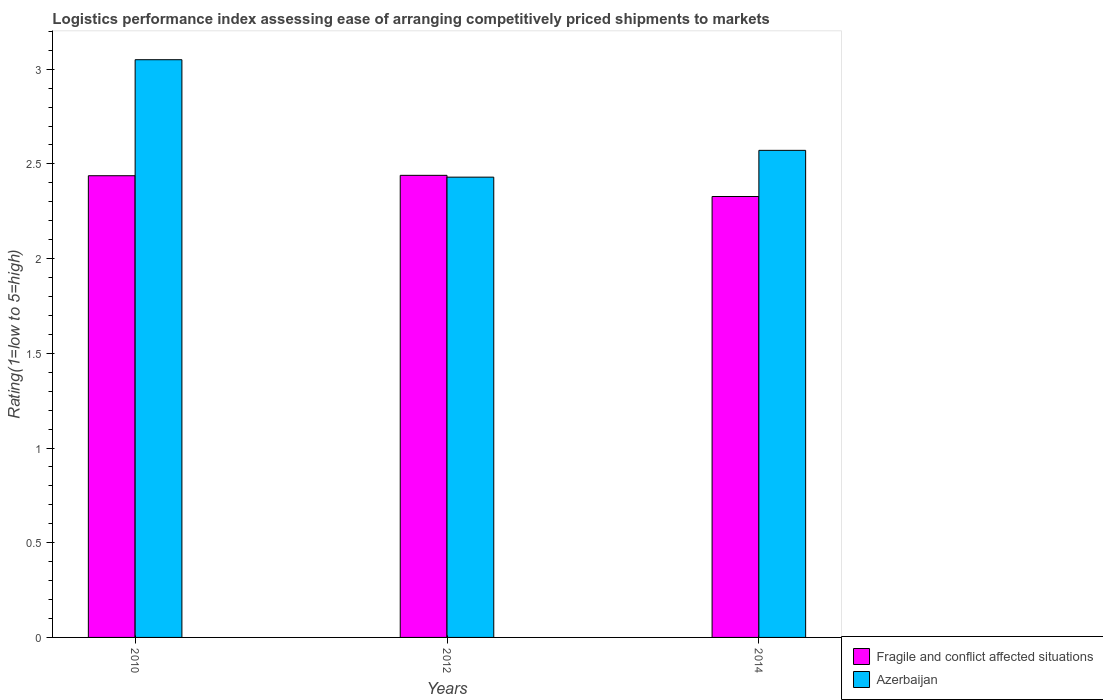How many bars are there on the 2nd tick from the left?
Your answer should be compact. 2. How many bars are there on the 1st tick from the right?
Make the answer very short. 2. What is the label of the 3rd group of bars from the left?
Ensure brevity in your answer.  2014. In how many cases, is the number of bars for a given year not equal to the number of legend labels?
Your answer should be compact. 0. What is the Logistic performance index in Azerbaijan in 2014?
Offer a very short reply. 2.57. Across all years, what is the maximum Logistic performance index in Azerbaijan?
Your answer should be compact. 3.05. Across all years, what is the minimum Logistic performance index in Fragile and conflict affected situations?
Your answer should be very brief. 2.33. In which year was the Logistic performance index in Azerbaijan maximum?
Ensure brevity in your answer.  2010. In which year was the Logistic performance index in Fragile and conflict affected situations minimum?
Provide a succinct answer. 2014. What is the total Logistic performance index in Azerbaijan in the graph?
Keep it short and to the point. 8.05. What is the difference between the Logistic performance index in Fragile and conflict affected situations in 2012 and that in 2014?
Keep it short and to the point. 0.11. What is the difference between the Logistic performance index in Fragile and conflict affected situations in 2010 and the Logistic performance index in Azerbaijan in 2014?
Your response must be concise. -0.13. What is the average Logistic performance index in Fragile and conflict affected situations per year?
Ensure brevity in your answer.  2.4. In the year 2012, what is the difference between the Logistic performance index in Azerbaijan and Logistic performance index in Fragile and conflict affected situations?
Offer a terse response. -0.01. In how many years, is the Logistic performance index in Azerbaijan greater than 0.8?
Give a very brief answer. 3. What is the ratio of the Logistic performance index in Fragile and conflict affected situations in 2012 to that in 2014?
Your answer should be compact. 1.05. What is the difference between the highest and the second highest Logistic performance index in Fragile and conflict affected situations?
Your response must be concise. 0. What is the difference between the highest and the lowest Logistic performance index in Azerbaijan?
Your answer should be very brief. 0.62. In how many years, is the Logistic performance index in Fragile and conflict affected situations greater than the average Logistic performance index in Fragile and conflict affected situations taken over all years?
Provide a succinct answer. 2. What does the 2nd bar from the left in 2012 represents?
Make the answer very short. Azerbaijan. What does the 1st bar from the right in 2012 represents?
Offer a terse response. Azerbaijan. How many years are there in the graph?
Your answer should be compact. 3. What is the difference between two consecutive major ticks on the Y-axis?
Your answer should be compact. 0.5. Does the graph contain any zero values?
Make the answer very short. No. Does the graph contain grids?
Your answer should be very brief. No. How many legend labels are there?
Provide a succinct answer. 2. How are the legend labels stacked?
Your response must be concise. Vertical. What is the title of the graph?
Your answer should be very brief. Logistics performance index assessing ease of arranging competitively priced shipments to markets. Does "Montenegro" appear as one of the legend labels in the graph?
Your answer should be very brief. No. What is the label or title of the Y-axis?
Your answer should be compact. Rating(1=low to 5=high). What is the Rating(1=low to 5=high) of Fragile and conflict affected situations in 2010?
Make the answer very short. 2.44. What is the Rating(1=low to 5=high) in Azerbaijan in 2010?
Keep it short and to the point. 3.05. What is the Rating(1=low to 5=high) in Fragile and conflict affected situations in 2012?
Keep it short and to the point. 2.44. What is the Rating(1=low to 5=high) of Azerbaijan in 2012?
Offer a very short reply. 2.43. What is the Rating(1=low to 5=high) in Fragile and conflict affected situations in 2014?
Give a very brief answer. 2.33. What is the Rating(1=low to 5=high) in Azerbaijan in 2014?
Provide a short and direct response. 2.57. Across all years, what is the maximum Rating(1=low to 5=high) of Fragile and conflict affected situations?
Your answer should be very brief. 2.44. Across all years, what is the maximum Rating(1=low to 5=high) in Azerbaijan?
Your response must be concise. 3.05. Across all years, what is the minimum Rating(1=low to 5=high) of Fragile and conflict affected situations?
Provide a succinct answer. 2.33. Across all years, what is the minimum Rating(1=low to 5=high) in Azerbaijan?
Make the answer very short. 2.43. What is the total Rating(1=low to 5=high) in Fragile and conflict affected situations in the graph?
Ensure brevity in your answer.  7.2. What is the total Rating(1=low to 5=high) in Azerbaijan in the graph?
Provide a short and direct response. 8.05. What is the difference between the Rating(1=low to 5=high) of Fragile and conflict affected situations in 2010 and that in 2012?
Provide a short and direct response. -0. What is the difference between the Rating(1=low to 5=high) in Azerbaijan in 2010 and that in 2012?
Your answer should be very brief. 0.62. What is the difference between the Rating(1=low to 5=high) in Fragile and conflict affected situations in 2010 and that in 2014?
Your response must be concise. 0.11. What is the difference between the Rating(1=low to 5=high) of Azerbaijan in 2010 and that in 2014?
Your answer should be compact. 0.48. What is the difference between the Rating(1=low to 5=high) of Fragile and conflict affected situations in 2012 and that in 2014?
Keep it short and to the point. 0.11. What is the difference between the Rating(1=low to 5=high) of Azerbaijan in 2012 and that in 2014?
Your answer should be compact. -0.14. What is the difference between the Rating(1=low to 5=high) in Fragile and conflict affected situations in 2010 and the Rating(1=low to 5=high) in Azerbaijan in 2012?
Your response must be concise. 0.01. What is the difference between the Rating(1=low to 5=high) of Fragile and conflict affected situations in 2010 and the Rating(1=low to 5=high) of Azerbaijan in 2014?
Your answer should be compact. -0.13. What is the difference between the Rating(1=low to 5=high) of Fragile and conflict affected situations in 2012 and the Rating(1=low to 5=high) of Azerbaijan in 2014?
Your answer should be compact. -0.13. What is the average Rating(1=low to 5=high) of Fragile and conflict affected situations per year?
Keep it short and to the point. 2.4. What is the average Rating(1=low to 5=high) in Azerbaijan per year?
Your answer should be compact. 2.68. In the year 2010, what is the difference between the Rating(1=low to 5=high) in Fragile and conflict affected situations and Rating(1=low to 5=high) in Azerbaijan?
Offer a terse response. -0.61. In the year 2012, what is the difference between the Rating(1=low to 5=high) of Fragile and conflict affected situations and Rating(1=low to 5=high) of Azerbaijan?
Your answer should be very brief. 0.01. In the year 2014, what is the difference between the Rating(1=low to 5=high) of Fragile and conflict affected situations and Rating(1=low to 5=high) of Azerbaijan?
Offer a terse response. -0.24. What is the ratio of the Rating(1=low to 5=high) of Fragile and conflict affected situations in 2010 to that in 2012?
Ensure brevity in your answer.  1. What is the ratio of the Rating(1=low to 5=high) in Azerbaijan in 2010 to that in 2012?
Ensure brevity in your answer.  1.26. What is the ratio of the Rating(1=low to 5=high) of Fragile and conflict affected situations in 2010 to that in 2014?
Your response must be concise. 1.05. What is the ratio of the Rating(1=low to 5=high) of Azerbaijan in 2010 to that in 2014?
Keep it short and to the point. 1.19. What is the ratio of the Rating(1=low to 5=high) in Fragile and conflict affected situations in 2012 to that in 2014?
Give a very brief answer. 1.05. What is the ratio of the Rating(1=low to 5=high) in Azerbaijan in 2012 to that in 2014?
Give a very brief answer. 0.94. What is the difference between the highest and the second highest Rating(1=low to 5=high) of Fragile and conflict affected situations?
Keep it short and to the point. 0. What is the difference between the highest and the second highest Rating(1=low to 5=high) of Azerbaijan?
Provide a short and direct response. 0.48. What is the difference between the highest and the lowest Rating(1=low to 5=high) of Fragile and conflict affected situations?
Provide a succinct answer. 0.11. What is the difference between the highest and the lowest Rating(1=low to 5=high) in Azerbaijan?
Provide a short and direct response. 0.62. 